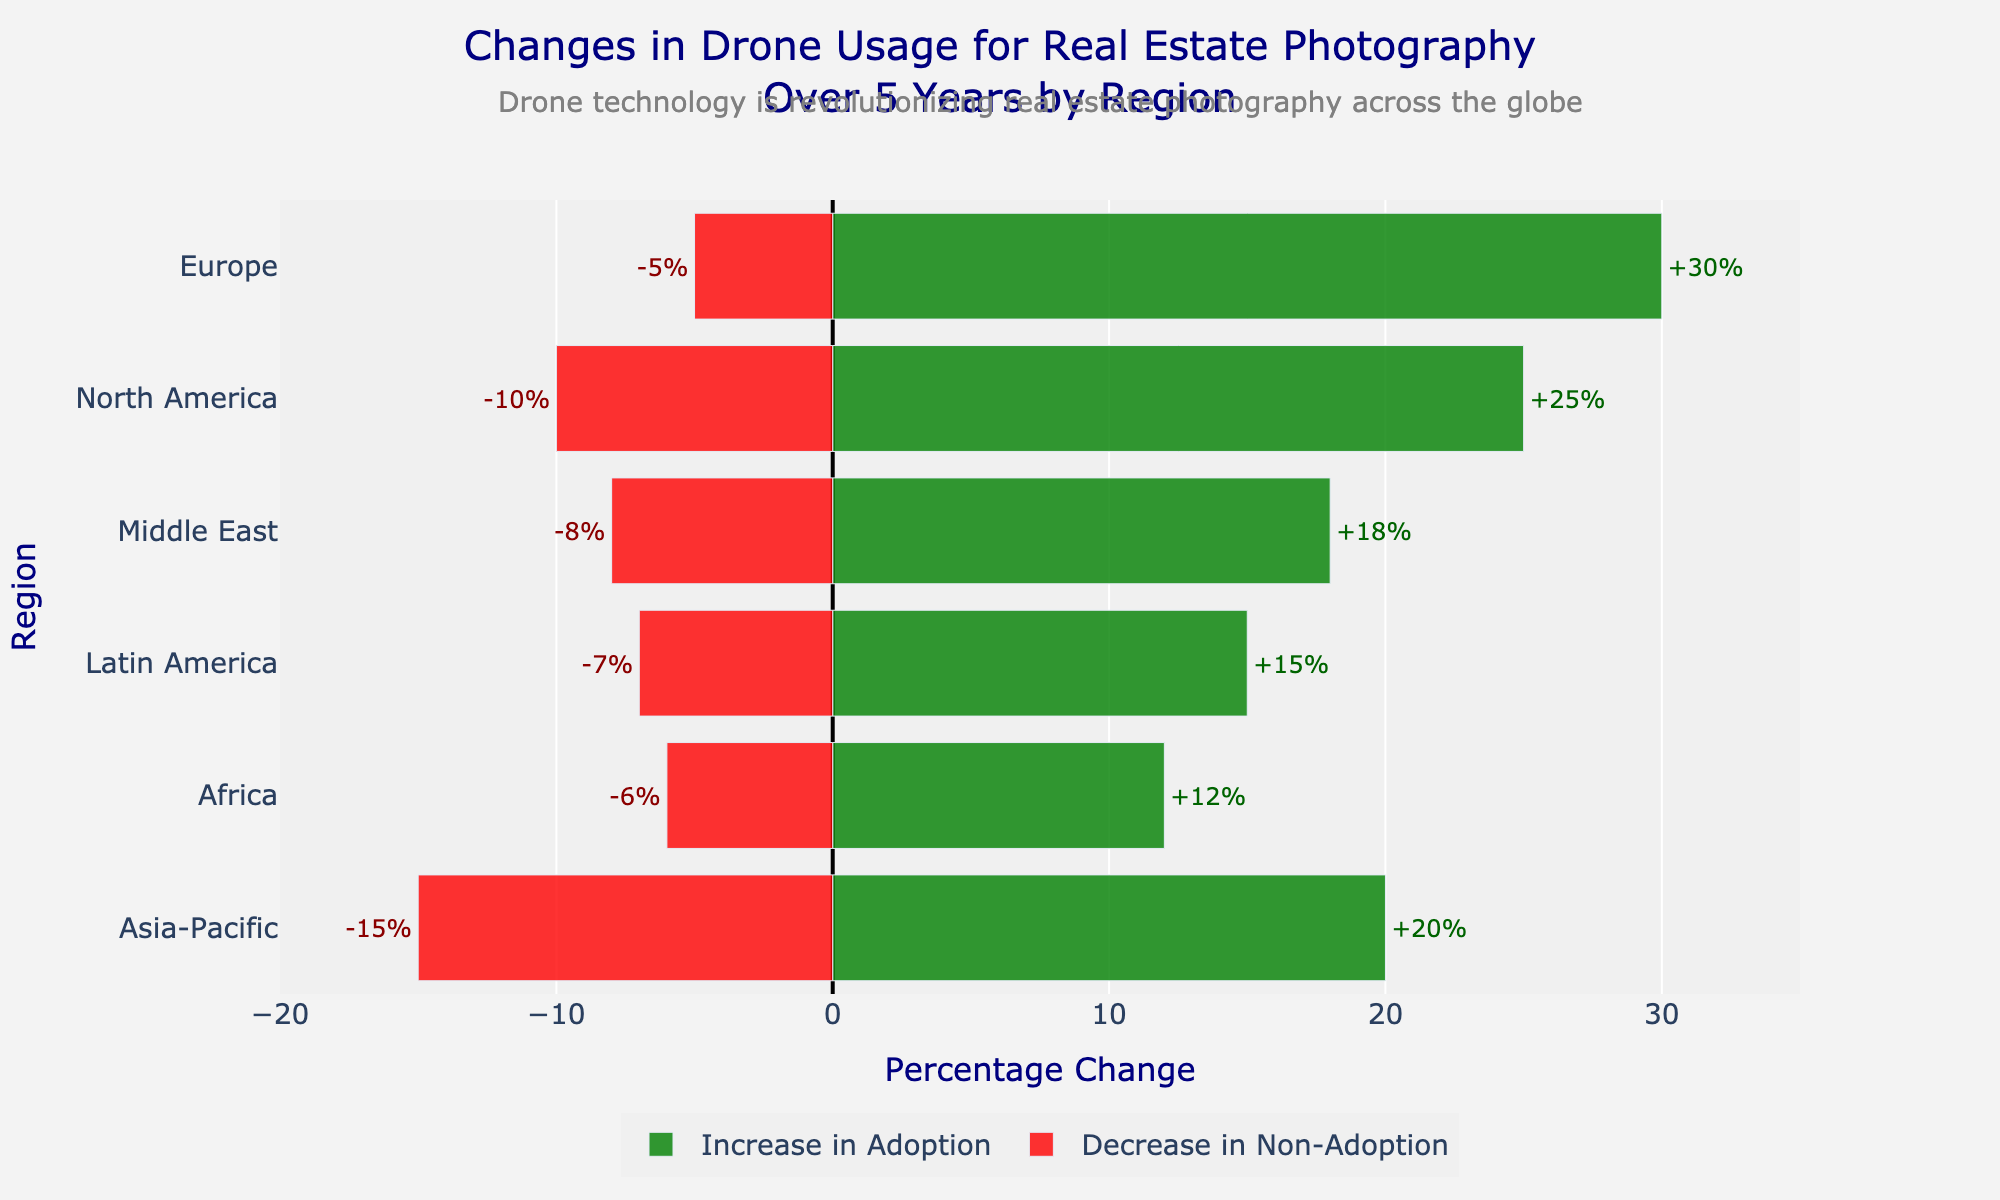What region shows the largest increase in adoption rate of drone usage for real estate photography? Look at the green bars for each region and identify the one with the longest bar representing the increase in adoption rate. Europe has the longest green bar.
Answer: Europe Which region experienced the smallest decrease in non-adoption rate? Observe the red bars which indicate the decrease in non-adoption rate and find the region with the shortest red bar. Europe has the shortest red bar.
Answer: Europe How much is the total percentage change in the adoption rate for the Middle East? The total percentage change can be found by adding the increase in adoption rate with the absolute value of the decrease in non-adoption rate for the Middle East. Middle East shows +18% increase in adoption rate and -8% decrease in non-adoption rate, resulting in a total of 18 + 8 = 26%.
Answer: 26% Compare the total changes in drone adoption rates between North America and Asia-Pacific. Which region shows a higher increase? Calculate the total change for both regions by summing the increase in adoption rate and the absolute decrease in non-adoption rate. North America has +25% and -10%, total change = 25 + 10 = 35%; Asia-Pacific has +20% and -15%, total change = 20 + 15 = 35%; both regions have the same total change.
Answer: Both are equal Rank the regions from highest to lowest in terms of the increase in adoption rate. Ordering the green bars from longest to shortest to determine the ranking: Europe (30%), North America (25%), Asia-Pacific (20%), Middle East (18%), Latin America (15%), Africa (12%)
Answer: Europe, North America, Asia-Pacific, Middle East, Latin America, Africa What is the combined effect of changes in adoption rates for the Africa region? Add the increase in adoption rate to the absolute value of the decrease in non-adoption rate for Africa. Africa shows +12% increase and -6% decrease in non-adoption rate. So, 12 + 6 = 18%.
Answer: 18% How does the decrease in non-adoption rate in the Asia-Pacific region compare to that of the Latin America region? Compare the lengths of the red bars for Asia-Pacific and Latin America. Asia-Pacific's decrease is -15% while Latin America is -7%, so Asia-Pacific has a larger decrease in non-adoption rate.
Answer: Asia-Pacific What is the visual indication that shows how drone technology is revolutionizing real estate photography worldwide mentioned in the annotation? The annotation indicates that both increases in adoption and decreases in non-adoption across multiple regions are being illustrated and validated by the diverging bars. The overall positive changes (green bars) and negative changes (red bars) showcase the global trend.
Answer: Positive and negative changes across regions Which region exhibits a balanced progression both in increase in adoption and decrease in non-adoption rates? Look for a region with relatively equal lengths of green and red bars to indicate a balanced performance. North America exhibits +25% increase against -10% decrease, more balanced regions are neither Asia-Pacific (+20%, -15%) nor Middle East (+18%, -8%). North America has more balanced increments and decrements in adoption.
Answer: North America 